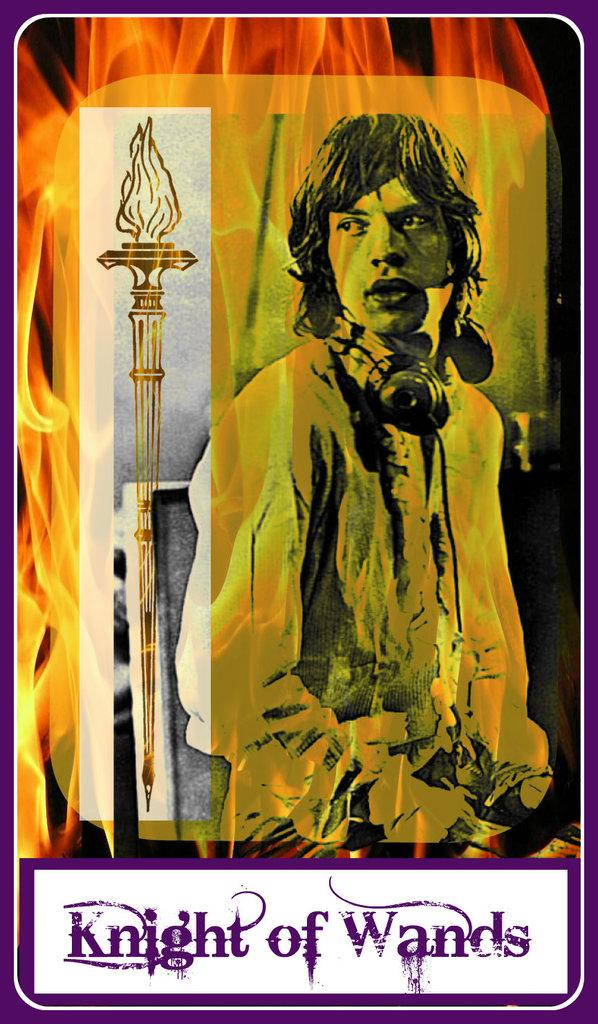<image>
Write a terse but informative summary of the picture. A man and a staff with Knight of Wands below it. 